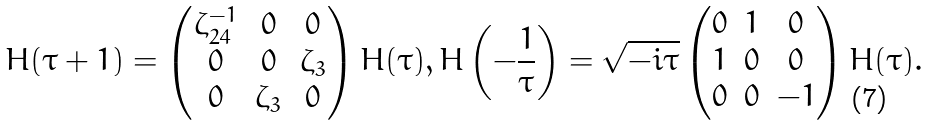<formula> <loc_0><loc_0><loc_500><loc_500>H ( \tau + 1 ) = \begin{pmatrix} \zeta _ { 2 4 } ^ { - 1 } & 0 & 0 \\ 0 & 0 & \zeta _ { 3 } \\ 0 & \zeta _ { 3 } & 0 \end{pmatrix} H ( \tau ) , H \left ( - \frac { 1 } { \tau } \right ) = \sqrt { - i \tau } \begin{pmatrix} 0 & 1 & 0 \\ 1 & 0 & 0 \\ 0 & 0 & - 1 \end{pmatrix} H ( \tau ) .</formula> 